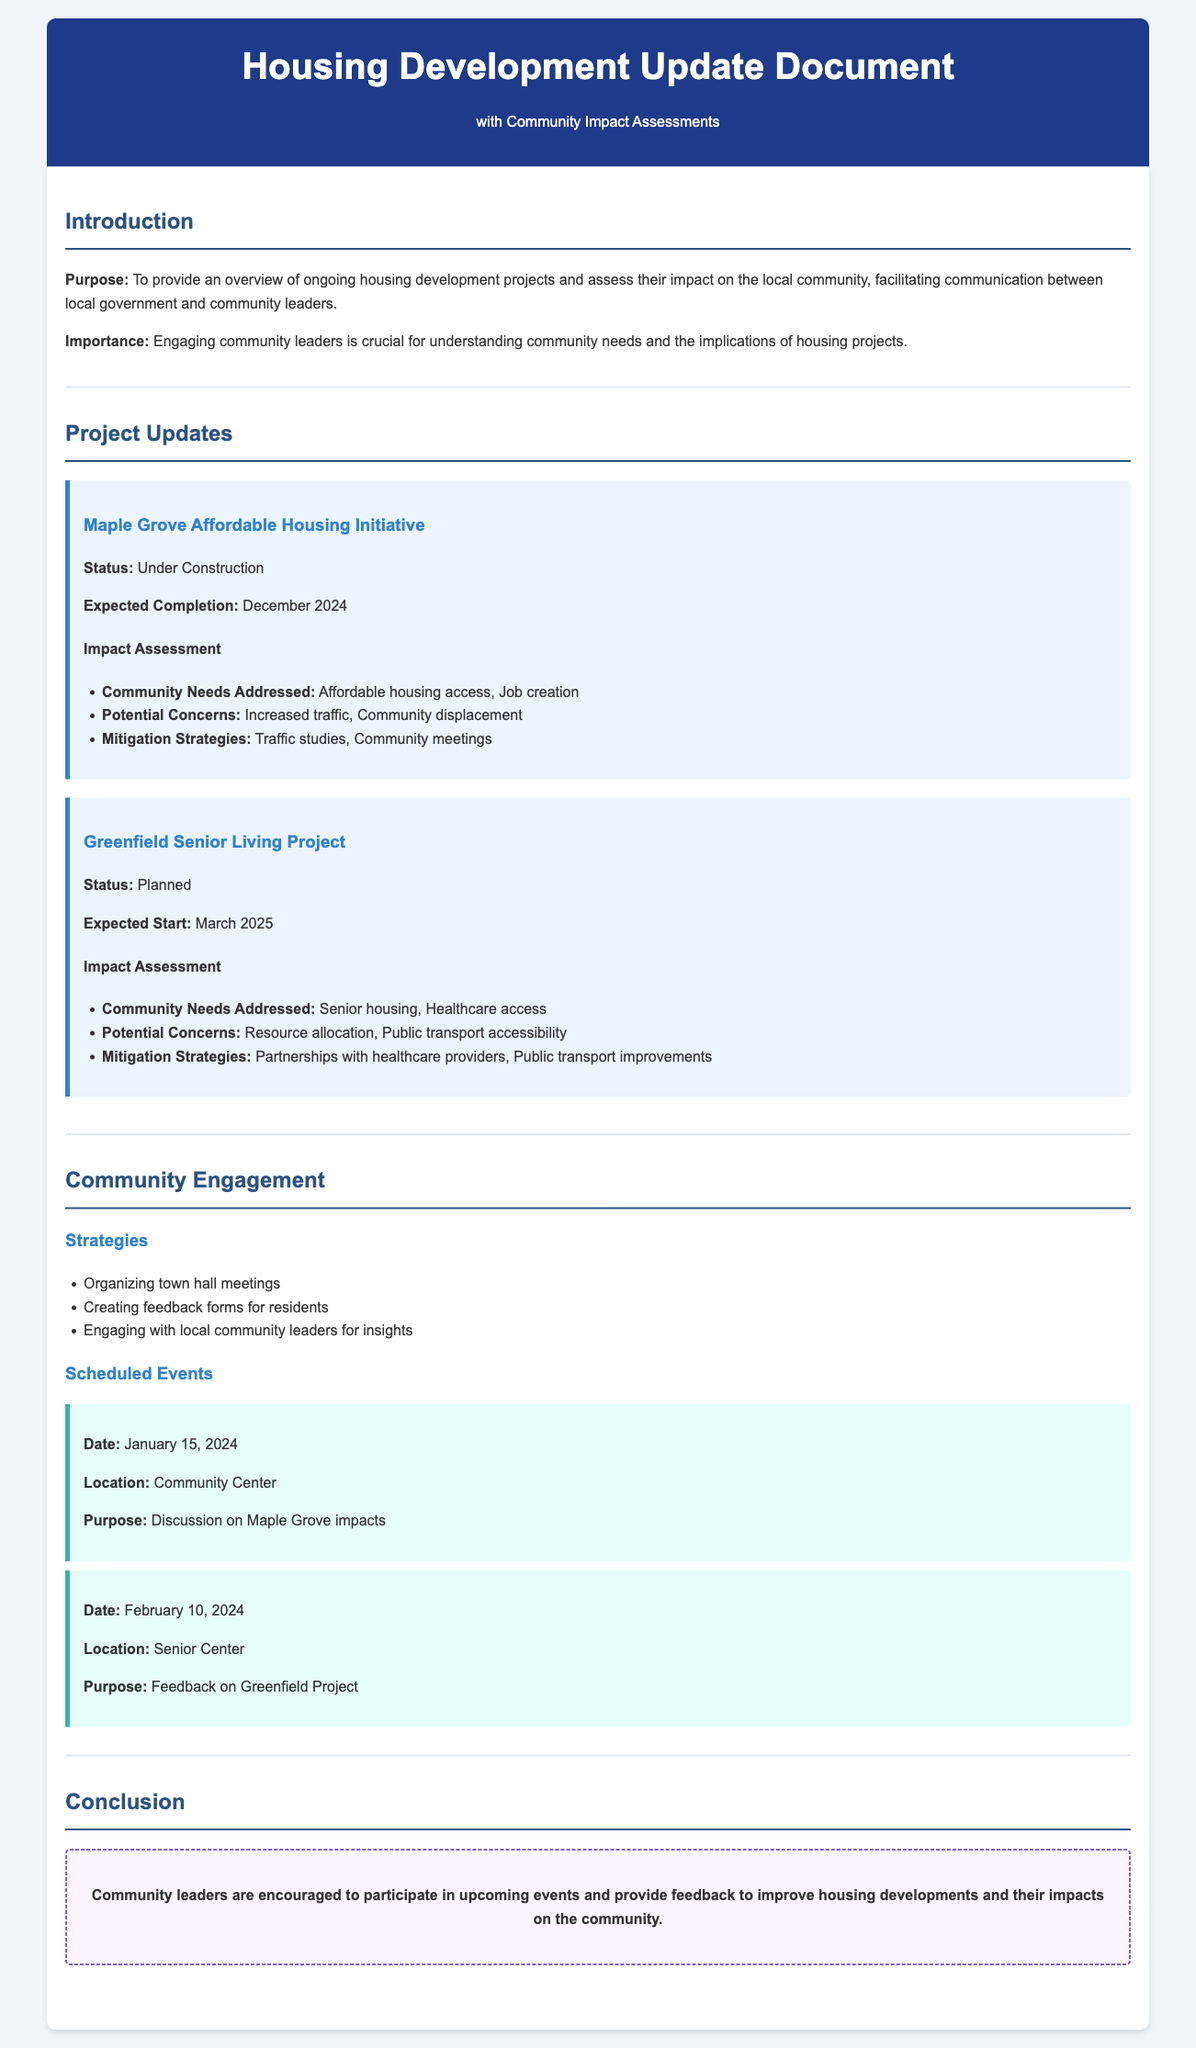what is the purpose of the document? The purpose is to provide an overview of ongoing housing development projects and assess their impact on the local community.
Answer: overview of ongoing housing development projects and assess their impact on the local community what is the expected completion date for the Maple Grove Affordable Housing Initiative? The document states that the expected completion date is December 2024.
Answer: December 2024 what community needs does the Greenfield Senior Living Project address? The document lists senior housing and healthcare access as the community needs addressed.
Answer: Senior housing, Healthcare access what mitigation strategy is proposed for the Maple Grove project's potential concerns? The document mentions traffic studies and community meetings as mitigation strategies.
Answer: Traffic studies, Community meetings how many scheduled events are mentioned in the Community Engagement section? The document lists two scheduled events for community engagement.
Answer: 2 which community center will host the event on January 15, 2024? The document specifies that the event will be held at the Community Center.
Answer: Community Center what is one concern regarding the Greenfield Senior Living Project? The document indicates that resource allocation is a potential concern.
Answer: Resource allocation what date is scheduled for feedback on the Greenfield Project? The document states that feedback on the Greenfield Project is scheduled for February 10, 2024.
Answer: February 10, 2024 what type of events are organized for community engagement? The document indicates that town hall meetings are organized as a strategy for community engagement.
Answer: town hall meetings 